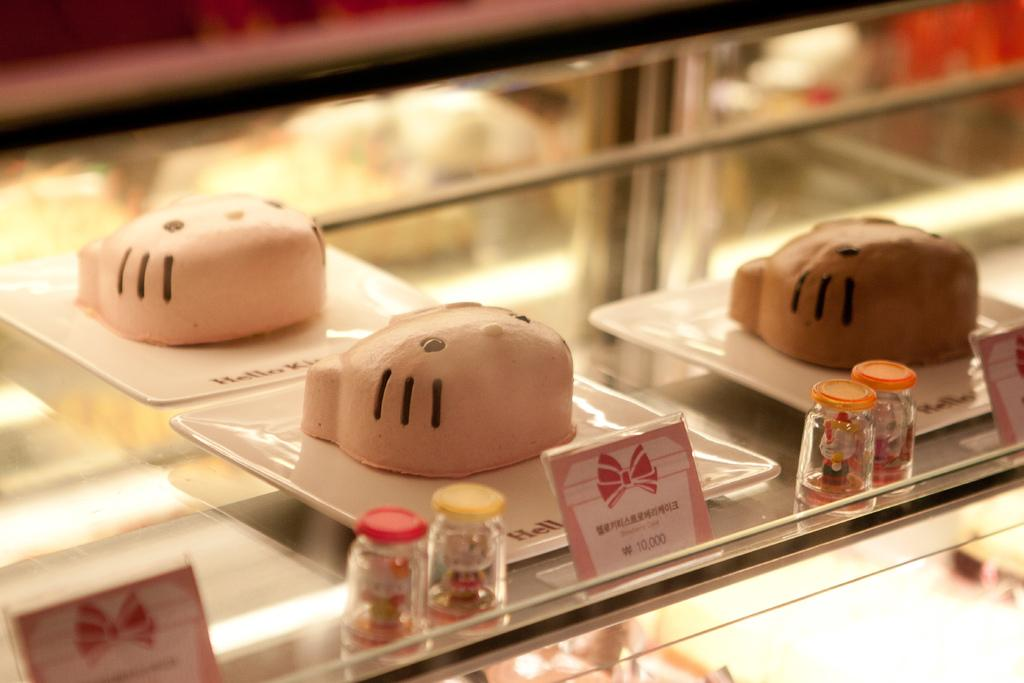What is the main structure visible in the image? There is a glass rack in the image. What is placed on the glass rack? There are trays on the glass rack. What type of cakes are on the trays? There are cakes in the shape of cat faces on the trays. What else can be seen in the image besides the glass rack and cakes? There are small bottles and price tags in the image. How does the wealth of the cat-shaped cakes affect the rainstorm outside? There is no mention of a rainstorm or the wealth of the cat-shaped cakes in the image. The image only shows a glass rack with trays containing cat-shaped cakes, small bottles, and price tags. 